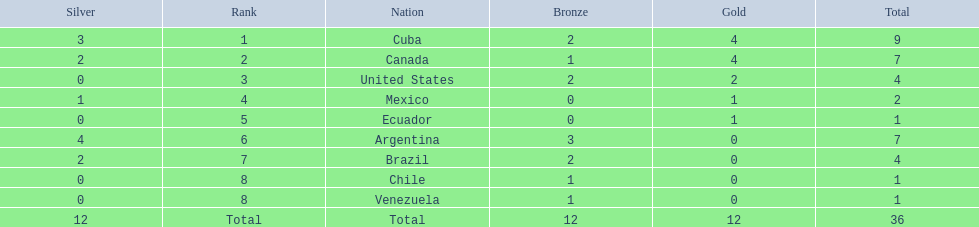Which countries have won gold medals? Cuba, Canada, United States, Mexico, Ecuador. Of these countries, which ones have never won silver or bronze medals? United States, Ecuador. Of the two nations listed previously, which one has only won a gold medal? Ecuador. 